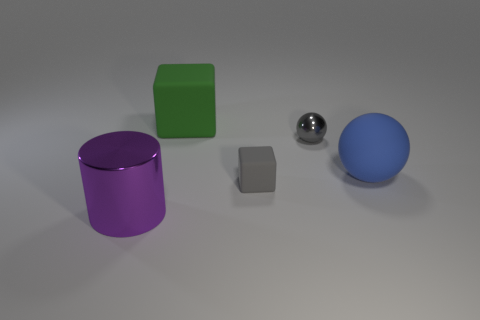Are there any other things that are the same color as the small matte block?
Offer a terse response. Yes. Is the color of the metallic sphere the same as the matte thing in front of the matte sphere?
Make the answer very short. Yes. What is the color of the cylinder that is the same size as the green matte object?
Your response must be concise. Purple. There is a matte object that is the same color as the tiny metallic sphere; what shape is it?
Provide a succinct answer. Cube. What material is the large object that is to the left of the rubber block behind the big ball made of?
Provide a succinct answer. Metal. Is the tiny shiny thing the same shape as the blue rubber object?
Provide a short and direct response. Yes. What is the color of the matte thing that is on the right side of the tiny gray thing that is left of the gray object behind the big rubber ball?
Ensure brevity in your answer.  Blue. How many large blue matte things are the same shape as the gray shiny thing?
Make the answer very short. 1. What size is the cube that is behind the block that is in front of the gray metal thing?
Keep it short and to the point. Large. Do the green object and the purple object have the same size?
Give a very brief answer. Yes. 